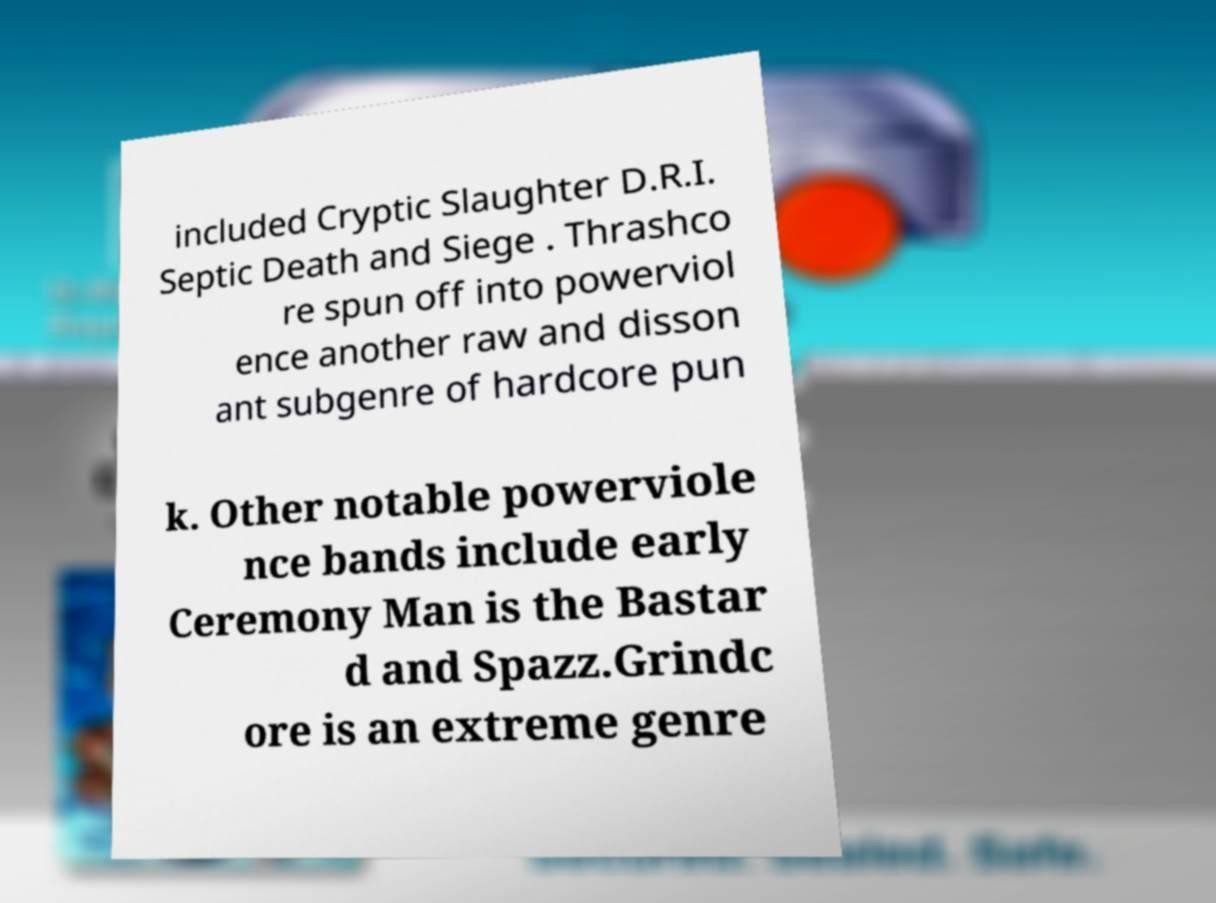Could you assist in decoding the text presented in this image and type it out clearly? included Cryptic Slaughter D.R.I. Septic Death and Siege . Thrashco re spun off into powerviol ence another raw and disson ant subgenre of hardcore pun k. Other notable powerviole nce bands include early Ceremony Man is the Bastar d and Spazz.Grindc ore is an extreme genre 